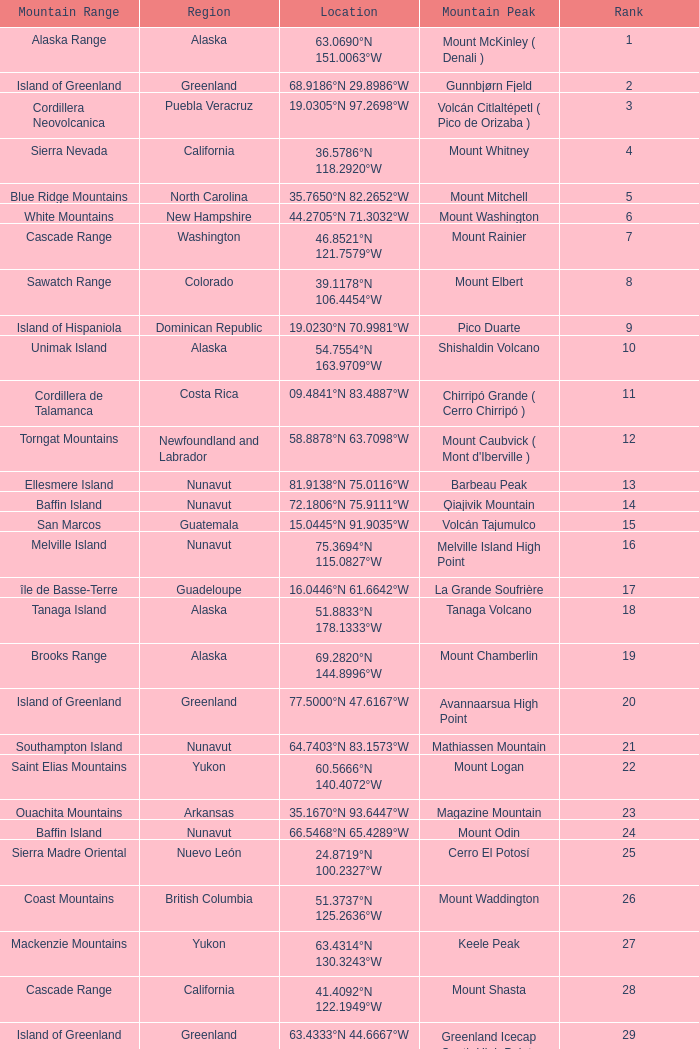Name the Mountain Peak which has a Rank of 62? Cerro Nube ( Quie Yelaag ). 